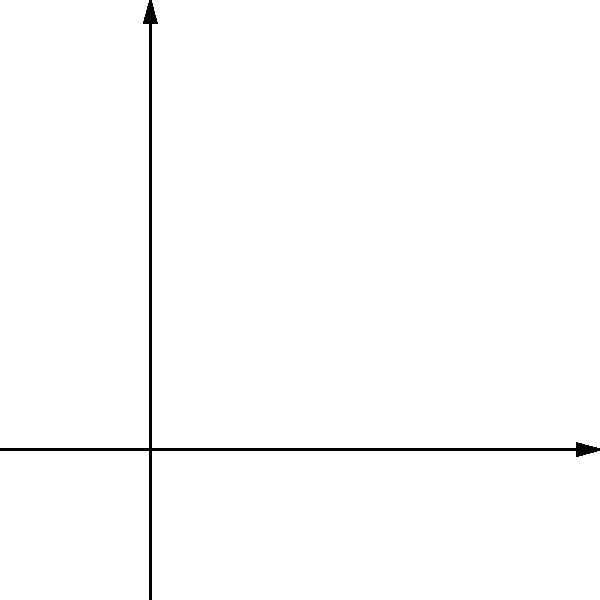In a robotics competition, you need to optimize the placement of sensors on your robot. The current sensor configuration is represented by basis vectors $\vec{v}_1$ and $\vec{v}_2$ (blue). You want to rotate the sensors by 45° counterclockwise to achieve better coverage, represented by basis vectors $\vec{u}_1$ and $\vec{u}_2$ (red). What is the transformation matrix $T$ that maps the original basis to the rotated basis? To find the transformation matrix $T$, we need to follow these steps:

1) First, recall that a 2D rotation matrix for a counterclockwise rotation by angle $\theta$ is given by:

   $$R(\theta) = \begin{bmatrix} \cos\theta & -\sin\theta \\ \sin\theta & \cos\theta \end{bmatrix}$$

2) In this case, we're rotating by 45° (π/4 radians) counterclockwise. So, we need:

   $$R(\pi/4) = \begin{bmatrix} \cos(\pi/4) & -\sin(\pi/4) \\ \sin(\pi/4) & \cos(\pi/4) \end{bmatrix}$$

3) We know that $\cos(\pi/4) = \sin(\pi/4) = \frac{1}{\sqrt{2}}$, so:

   $$R(\pi/4) = \begin{bmatrix} \frac{1}{\sqrt{2}} & -\frac{1}{\sqrt{2}} \\ \frac{1}{\sqrt{2}} & \frac{1}{\sqrt{2}} \end{bmatrix}$$

4) This rotation matrix $R(\pi/4)$ is exactly the transformation matrix $T$ we're looking for, as it maps the standard basis (representing our original sensor configuration) to the rotated basis (representing our new sensor configuration).

Therefore, the transformation matrix $T$ is:

$$T = \begin{bmatrix} \frac{1}{\sqrt{2}} & -\frac{1}{\sqrt{2}} \\ \frac{1}{\sqrt{2}} & \frac{1}{\sqrt{2}} \end{bmatrix}$$
Answer: $\begin{bmatrix} \frac{1}{\sqrt{2}} & -\frac{1}{\sqrt{2}} \\ \frac{1}{\sqrt{2}} & \frac{1}{\sqrt{2}} \end{bmatrix}$ 